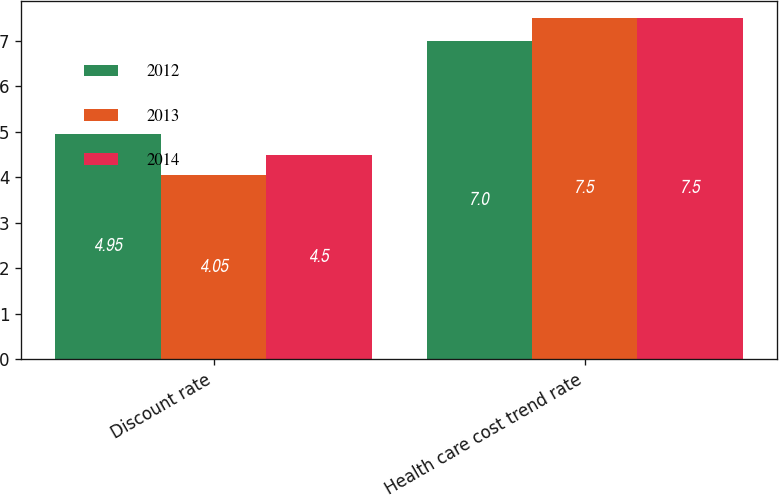Convert chart to OTSL. <chart><loc_0><loc_0><loc_500><loc_500><stacked_bar_chart><ecel><fcel>Discount rate<fcel>Health care cost trend rate<nl><fcel>2012<fcel>4.95<fcel>7<nl><fcel>2013<fcel>4.05<fcel>7.5<nl><fcel>2014<fcel>4.5<fcel>7.5<nl></chart> 